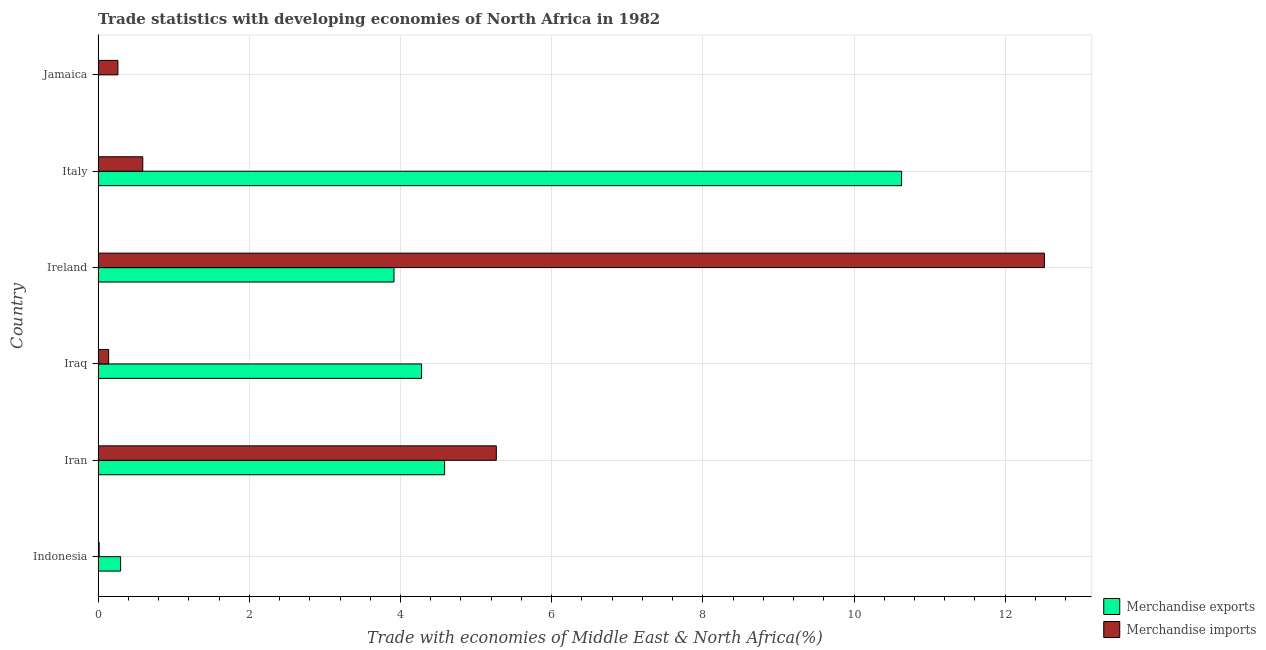How many groups of bars are there?
Keep it short and to the point. 6. Are the number of bars per tick equal to the number of legend labels?
Offer a terse response. Yes. How many bars are there on the 6th tick from the top?
Your response must be concise. 2. What is the label of the 6th group of bars from the top?
Make the answer very short. Indonesia. What is the merchandise exports in Italy?
Make the answer very short. 10.63. Across all countries, what is the maximum merchandise imports?
Provide a short and direct response. 12.52. Across all countries, what is the minimum merchandise exports?
Your answer should be very brief. 0. In which country was the merchandise imports maximum?
Provide a succinct answer. Ireland. In which country was the merchandise exports minimum?
Your answer should be very brief. Jamaica. What is the total merchandise imports in the graph?
Your response must be concise. 18.79. What is the difference between the merchandise exports in Indonesia and that in Iran?
Your response must be concise. -4.29. What is the difference between the merchandise exports in Iran and the merchandise imports in Indonesia?
Keep it short and to the point. 4.57. What is the average merchandise imports per country?
Keep it short and to the point. 3.13. What is the difference between the merchandise imports and merchandise exports in Indonesia?
Provide a succinct answer. -0.28. In how many countries, is the merchandise exports greater than 2.8 %?
Give a very brief answer. 4. What is the ratio of the merchandise exports in Iran to that in Ireland?
Offer a terse response. 1.17. Is the difference between the merchandise exports in Iraq and Ireland greater than the difference between the merchandise imports in Iraq and Ireland?
Offer a terse response. Yes. What is the difference between the highest and the second highest merchandise exports?
Ensure brevity in your answer.  6.05. What is the difference between the highest and the lowest merchandise exports?
Your answer should be very brief. 10.63. Is the sum of the merchandise imports in Ireland and Italy greater than the maximum merchandise exports across all countries?
Ensure brevity in your answer.  Yes. What does the 1st bar from the top in Ireland represents?
Make the answer very short. Merchandise imports. Are all the bars in the graph horizontal?
Provide a succinct answer. Yes. How many countries are there in the graph?
Offer a very short reply. 6. Are the values on the major ticks of X-axis written in scientific E-notation?
Ensure brevity in your answer.  No. How many legend labels are there?
Your answer should be very brief. 2. What is the title of the graph?
Your response must be concise. Trade statistics with developing economies of North Africa in 1982. Does "Lower secondary education" appear as one of the legend labels in the graph?
Give a very brief answer. No. What is the label or title of the X-axis?
Give a very brief answer. Trade with economies of Middle East & North Africa(%). What is the label or title of the Y-axis?
Ensure brevity in your answer.  Country. What is the Trade with economies of Middle East & North Africa(%) of Merchandise exports in Indonesia?
Offer a terse response. 0.3. What is the Trade with economies of Middle East & North Africa(%) of Merchandise imports in Indonesia?
Offer a very short reply. 0.01. What is the Trade with economies of Middle East & North Africa(%) in Merchandise exports in Iran?
Provide a succinct answer. 4.58. What is the Trade with economies of Middle East & North Africa(%) in Merchandise imports in Iran?
Your answer should be very brief. 5.27. What is the Trade with economies of Middle East & North Africa(%) of Merchandise exports in Iraq?
Provide a succinct answer. 4.28. What is the Trade with economies of Middle East & North Africa(%) in Merchandise imports in Iraq?
Provide a short and direct response. 0.14. What is the Trade with economies of Middle East & North Africa(%) in Merchandise exports in Ireland?
Your answer should be compact. 3.91. What is the Trade with economies of Middle East & North Africa(%) in Merchandise imports in Ireland?
Keep it short and to the point. 12.52. What is the Trade with economies of Middle East & North Africa(%) in Merchandise exports in Italy?
Ensure brevity in your answer.  10.63. What is the Trade with economies of Middle East & North Africa(%) of Merchandise imports in Italy?
Your response must be concise. 0.59. What is the Trade with economies of Middle East & North Africa(%) in Merchandise exports in Jamaica?
Your answer should be very brief. 0. What is the Trade with economies of Middle East & North Africa(%) in Merchandise imports in Jamaica?
Give a very brief answer. 0.26. Across all countries, what is the maximum Trade with economies of Middle East & North Africa(%) in Merchandise exports?
Ensure brevity in your answer.  10.63. Across all countries, what is the maximum Trade with economies of Middle East & North Africa(%) of Merchandise imports?
Your response must be concise. 12.52. Across all countries, what is the minimum Trade with economies of Middle East & North Africa(%) of Merchandise exports?
Your response must be concise. 0. Across all countries, what is the minimum Trade with economies of Middle East & North Africa(%) of Merchandise imports?
Your answer should be very brief. 0.01. What is the total Trade with economies of Middle East & North Africa(%) in Merchandise exports in the graph?
Your answer should be compact. 23.71. What is the total Trade with economies of Middle East & North Africa(%) in Merchandise imports in the graph?
Give a very brief answer. 18.79. What is the difference between the Trade with economies of Middle East & North Africa(%) in Merchandise exports in Indonesia and that in Iran?
Give a very brief answer. -4.29. What is the difference between the Trade with economies of Middle East & North Africa(%) of Merchandise imports in Indonesia and that in Iran?
Give a very brief answer. -5.25. What is the difference between the Trade with economies of Middle East & North Africa(%) in Merchandise exports in Indonesia and that in Iraq?
Offer a very short reply. -3.98. What is the difference between the Trade with economies of Middle East & North Africa(%) in Merchandise imports in Indonesia and that in Iraq?
Keep it short and to the point. -0.13. What is the difference between the Trade with economies of Middle East & North Africa(%) in Merchandise exports in Indonesia and that in Ireland?
Your answer should be very brief. -3.62. What is the difference between the Trade with economies of Middle East & North Africa(%) in Merchandise imports in Indonesia and that in Ireland?
Provide a succinct answer. -12.5. What is the difference between the Trade with economies of Middle East & North Africa(%) of Merchandise exports in Indonesia and that in Italy?
Make the answer very short. -10.33. What is the difference between the Trade with economies of Middle East & North Africa(%) of Merchandise imports in Indonesia and that in Italy?
Your answer should be very brief. -0.58. What is the difference between the Trade with economies of Middle East & North Africa(%) in Merchandise exports in Indonesia and that in Jamaica?
Keep it short and to the point. 0.29. What is the difference between the Trade with economies of Middle East & North Africa(%) of Merchandise imports in Indonesia and that in Jamaica?
Make the answer very short. -0.25. What is the difference between the Trade with economies of Middle East & North Africa(%) in Merchandise exports in Iran and that in Iraq?
Provide a succinct answer. 0.3. What is the difference between the Trade with economies of Middle East & North Africa(%) of Merchandise imports in Iran and that in Iraq?
Your response must be concise. 5.13. What is the difference between the Trade with economies of Middle East & North Africa(%) of Merchandise exports in Iran and that in Ireland?
Ensure brevity in your answer.  0.67. What is the difference between the Trade with economies of Middle East & North Africa(%) of Merchandise imports in Iran and that in Ireland?
Provide a short and direct response. -7.25. What is the difference between the Trade with economies of Middle East & North Africa(%) in Merchandise exports in Iran and that in Italy?
Provide a succinct answer. -6.05. What is the difference between the Trade with economies of Middle East & North Africa(%) in Merchandise imports in Iran and that in Italy?
Your answer should be compact. 4.68. What is the difference between the Trade with economies of Middle East & North Africa(%) in Merchandise exports in Iran and that in Jamaica?
Offer a very short reply. 4.58. What is the difference between the Trade with economies of Middle East & North Africa(%) in Merchandise imports in Iran and that in Jamaica?
Give a very brief answer. 5.01. What is the difference between the Trade with economies of Middle East & North Africa(%) in Merchandise exports in Iraq and that in Ireland?
Your response must be concise. 0.37. What is the difference between the Trade with economies of Middle East & North Africa(%) in Merchandise imports in Iraq and that in Ireland?
Give a very brief answer. -12.38. What is the difference between the Trade with economies of Middle East & North Africa(%) of Merchandise exports in Iraq and that in Italy?
Ensure brevity in your answer.  -6.35. What is the difference between the Trade with economies of Middle East & North Africa(%) in Merchandise imports in Iraq and that in Italy?
Your answer should be very brief. -0.45. What is the difference between the Trade with economies of Middle East & North Africa(%) in Merchandise exports in Iraq and that in Jamaica?
Make the answer very short. 4.28. What is the difference between the Trade with economies of Middle East & North Africa(%) in Merchandise imports in Iraq and that in Jamaica?
Your answer should be very brief. -0.12. What is the difference between the Trade with economies of Middle East & North Africa(%) of Merchandise exports in Ireland and that in Italy?
Offer a terse response. -6.72. What is the difference between the Trade with economies of Middle East & North Africa(%) of Merchandise imports in Ireland and that in Italy?
Offer a terse response. 11.93. What is the difference between the Trade with economies of Middle East & North Africa(%) of Merchandise exports in Ireland and that in Jamaica?
Offer a very short reply. 3.91. What is the difference between the Trade with economies of Middle East & North Africa(%) of Merchandise imports in Ireland and that in Jamaica?
Provide a succinct answer. 12.26. What is the difference between the Trade with economies of Middle East & North Africa(%) of Merchandise exports in Italy and that in Jamaica?
Your answer should be very brief. 10.63. What is the difference between the Trade with economies of Middle East & North Africa(%) of Merchandise imports in Italy and that in Jamaica?
Make the answer very short. 0.33. What is the difference between the Trade with economies of Middle East & North Africa(%) in Merchandise exports in Indonesia and the Trade with economies of Middle East & North Africa(%) in Merchandise imports in Iran?
Give a very brief answer. -4.97. What is the difference between the Trade with economies of Middle East & North Africa(%) in Merchandise exports in Indonesia and the Trade with economies of Middle East & North Africa(%) in Merchandise imports in Iraq?
Your answer should be compact. 0.16. What is the difference between the Trade with economies of Middle East & North Africa(%) of Merchandise exports in Indonesia and the Trade with economies of Middle East & North Africa(%) of Merchandise imports in Ireland?
Keep it short and to the point. -12.22. What is the difference between the Trade with economies of Middle East & North Africa(%) of Merchandise exports in Indonesia and the Trade with economies of Middle East & North Africa(%) of Merchandise imports in Italy?
Provide a short and direct response. -0.29. What is the difference between the Trade with economies of Middle East & North Africa(%) in Merchandise exports in Indonesia and the Trade with economies of Middle East & North Africa(%) in Merchandise imports in Jamaica?
Provide a short and direct response. 0.04. What is the difference between the Trade with economies of Middle East & North Africa(%) of Merchandise exports in Iran and the Trade with economies of Middle East & North Africa(%) of Merchandise imports in Iraq?
Your response must be concise. 4.44. What is the difference between the Trade with economies of Middle East & North Africa(%) of Merchandise exports in Iran and the Trade with economies of Middle East & North Africa(%) of Merchandise imports in Ireland?
Ensure brevity in your answer.  -7.93. What is the difference between the Trade with economies of Middle East & North Africa(%) in Merchandise exports in Iran and the Trade with economies of Middle East & North Africa(%) in Merchandise imports in Italy?
Give a very brief answer. 3.99. What is the difference between the Trade with economies of Middle East & North Africa(%) in Merchandise exports in Iran and the Trade with economies of Middle East & North Africa(%) in Merchandise imports in Jamaica?
Offer a very short reply. 4.32. What is the difference between the Trade with economies of Middle East & North Africa(%) in Merchandise exports in Iraq and the Trade with economies of Middle East & North Africa(%) in Merchandise imports in Ireland?
Make the answer very short. -8.24. What is the difference between the Trade with economies of Middle East & North Africa(%) of Merchandise exports in Iraq and the Trade with economies of Middle East & North Africa(%) of Merchandise imports in Italy?
Offer a very short reply. 3.69. What is the difference between the Trade with economies of Middle East & North Africa(%) of Merchandise exports in Iraq and the Trade with economies of Middle East & North Africa(%) of Merchandise imports in Jamaica?
Keep it short and to the point. 4.02. What is the difference between the Trade with economies of Middle East & North Africa(%) of Merchandise exports in Ireland and the Trade with economies of Middle East & North Africa(%) of Merchandise imports in Italy?
Ensure brevity in your answer.  3.32. What is the difference between the Trade with economies of Middle East & North Africa(%) in Merchandise exports in Ireland and the Trade with economies of Middle East & North Africa(%) in Merchandise imports in Jamaica?
Provide a short and direct response. 3.65. What is the difference between the Trade with economies of Middle East & North Africa(%) in Merchandise exports in Italy and the Trade with economies of Middle East & North Africa(%) in Merchandise imports in Jamaica?
Provide a short and direct response. 10.37. What is the average Trade with economies of Middle East & North Africa(%) in Merchandise exports per country?
Offer a very short reply. 3.95. What is the average Trade with economies of Middle East & North Africa(%) in Merchandise imports per country?
Your answer should be compact. 3.13. What is the difference between the Trade with economies of Middle East & North Africa(%) in Merchandise exports and Trade with economies of Middle East & North Africa(%) in Merchandise imports in Indonesia?
Provide a succinct answer. 0.28. What is the difference between the Trade with economies of Middle East & North Africa(%) in Merchandise exports and Trade with economies of Middle East & North Africa(%) in Merchandise imports in Iran?
Provide a short and direct response. -0.68. What is the difference between the Trade with economies of Middle East & North Africa(%) in Merchandise exports and Trade with economies of Middle East & North Africa(%) in Merchandise imports in Iraq?
Your answer should be compact. 4.14. What is the difference between the Trade with economies of Middle East & North Africa(%) in Merchandise exports and Trade with economies of Middle East & North Africa(%) in Merchandise imports in Ireland?
Make the answer very short. -8.6. What is the difference between the Trade with economies of Middle East & North Africa(%) of Merchandise exports and Trade with economies of Middle East & North Africa(%) of Merchandise imports in Italy?
Ensure brevity in your answer.  10.04. What is the difference between the Trade with economies of Middle East & North Africa(%) in Merchandise exports and Trade with economies of Middle East & North Africa(%) in Merchandise imports in Jamaica?
Offer a very short reply. -0.26. What is the ratio of the Trade with economies of Middle East & North Africa(%) in Merchandise exports in Indonesia to that in Iran?
Provide a short and direct response. 0.06. What is the ratio of the Trade with economies of Middle East & North Africa(%) in Merchandise imports in Indonesia to that in Iran?
Your response must be concise. 0. What is the ratio of the Trade with economies of Middle East & North Africa(%) in Merchandise exports in Indonesia to that in Iraq?
Provide a short and direct response. 0.07. What is the ratio of the Trade with economies of Middle East & North Africa(%) of Merchandise imports in Indonesia to that in Iraq?
Provide a succinct answer. 0.1. What is the ratio of the Trade with economies of Middle East & North Africa(%) of Merchandise exports in Indonesia to that in Ireland?
Offer a terse response. 0.08. What is the ratio of the Trade with economies of Middle East & North Africa(%) in Merchandise imports in Indonesia to that in Ireland?
Keep it short and to the point. 0. What is the ratio of the Trade with economies of Middle East & North Africa(%) of Merchandise exports in Indonesia to that in Italy?
Provide a succinct answer. 0.03. What is the ratio of the Trade with economies of Middle East & North Africa(%) of Merchandise imports in Indonesia to that in Italy?
Ensure brevity in your answer.  0.02. What is the ratio of the Trade with economies of Middle East & North Africa(%) in Merchandise exports in Indonesia to that in Jamaica?
Your response must be concise. 114.14. What is the ratio of the Trade with economies of Middle East & North Africa(%) in Merchandise imports in Indonesia to that in Jamaica?
Offer a terse response. 0.05. What is the ratio of the Trade with economies of Middle East & North Africa(%) in Merchandise exports in Iran to that in Iraq?
Offer a very short reply. 1.07. What is the ratio of the Trade with economies of Middle East & North Africa(%) in Merchandise imports in Iran to that in Iraq?
Your response must be concise. 37.81. What is the ratio of the Trade with economies of Middle East & North Africa(%) of Merchandise exports in Iran to that in Ireland?
Ensure brevity in your answer.  1.17. What is the ratio of the Trade with economies of Middle East & North Africa(%) of Merchandise imports in Iran to that in Ireland?
Provide a short and direct response. 0.42. What is the ratio of the Trade with economies of Middle East & North Africa(%) of Merchandise exports in Iran to that in Italy?
Offer a very short reply. 0.43. What is the ratio of the Trade with economies of Middle East & North Africa(%) in Merchandise imports in Iran to that in Italy?
Your answer should be very brief. 8.92. What is the ratio of the Trade with economies of Middle East & North Africa(%) of Merchandise exports in Iran to that in Jamaica?
Make the answer very short. 1758.76. What is the ratio of the Trade with economies of Middle East & North Africa(%) in Merchandise imports in Iran to that in Jamaica?
Your answer should be compact. 20.13. What is the ratio of the Trade with economies of Middle East & North Africa(%) of Merchandise exports in Iraq to that in Ireland?
Offer a terse response. 1.09. What is the ratio of the Trade with economies of Middle East & North Africa(%) of Merchandise imports in Iraq to that in Ireland?
Offer a terse response. 0.01. What is the ratio of the Trade with economies of Middle East & North Africa(%) in Merchandise exports in Iraq to that in Italy?
Your response must be concise. 0.4. What is the ratio of the Trade with economies of Middle East & North Africa(%) of Merchandise imports in Iraq to that in Italy?
Give a very brief answer. 0.24. What is the ratio of the Trade with economies of Middle East & North Africa(%) of Merchandise exports in Iraq to that in Jamaica?
Offer a very short reply. 1641.9. What is the ratio of the Trade with economies of Middle East & North Africa(%) of Merchandise imports in Iraq to that in Jamaica?
Give a very brief answer. 0.53. What is the ratio of the Trade with economies of Middle East & North Africa(%) in Merchandise exports in Ireland to that in Italy?
Provide a short and direct response. 0.37. What is the ratio of the Trade with economies of Middle East & North Africa(%) of Merchandise imports in Ireland to that in Italy?
Ensure brevity in your answer.  21.19. What is the ratio of the Trade with economies of Middle East & North Africa(%) of Merchandise exports in Ireland to that in Jamaica?
Make the answer very short. 1501.78. What is the ratio of the Trade with economies of Middle East & North Africa(%) of Merchandise imports in Ireland to that in Jamaica?
Give a very brief answer. 47.83. What is the ratio of the Trade with economies of Middle East & North Africa(%) in Merchandise exports in Italy to that in Jamaica?
Offer a very short reply. 4078.38. What is the ratio of the Trade with economies of Middle East & North Africa(%) in Merchandise imports in Italy to that in Jamaica?
Offer a very short reply. 2.26. What is the difference between the highest and the second highest Trade with economies of Middle East & North Africa(%) of Merchandise exports?
Keep it short and to the point. 6.05. What is the difference between the highest and the second highest Trade with economies of Middle East & North Africa(%) of Merchandise imports?
Offer a very short reply. 7.25. What is the difference between the highest and the lowest Trade with economies of Middle East & North Africa(%) in Merchandise exports?
Provide a short and direct response. 10.63. What is the difference between the highest and the lowest Trade with economies of Middle East & North Africa(%) of Merchandise imports?
Offer a terse response. 12.5. 